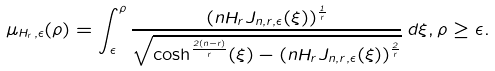Convert formula to latex. <formula><loc_0><loc_0><loc_500><loc_500>\mu _ { H _ { r } , \epsilon } ( \rho ) = \int _ { \epsilon } ^ { \rho } \frac { ( n H _ { r } J _ { n , r , \epsilon } ( \xi ) ) ^ { \frac { 1 } { r } } } { \sqrt { \cosh ^ { \frac { 2 ( n - r ) } { r } } ( \xi ) - ( n H _ { r } J _ { n , r , \epsilon } ( \xi ) ) ^ { \frac { 2 } { r } } } } \, d \xi , \rho \geq \epsilon .</formula> 